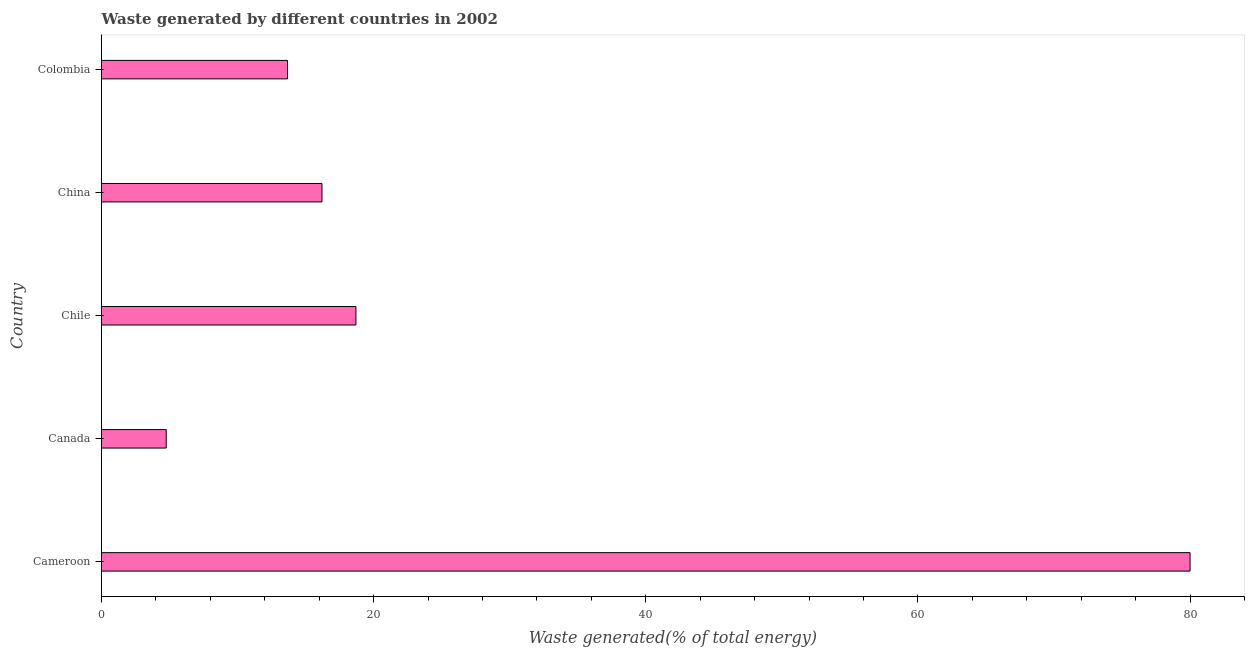What is the title of the graph?
Your response must be concise. Waste generated by different countries in 2002. What is the label or title of the X-axis?
Give a very brief answer. Waste generated(% of total energy). What is the label or title of the Y-axis?
Offer a very short reply. Country. What is the amount of waste generated in Cameroon?
Your answer should be compact. 80. Across all countries, what is the maximum amount of waste generated?
Provide a succinct answer. 80. Across all countries, what is the minimum amount of waste generated?
Provide a succinct answer. 4.76. In which country was the amount of waste generated maximum?
Your answer should be very brief. Cameroon. In which country was the amount of waste generated minimum?
Provide a succinct answer. Canada. What is the sum of the amount of waste generated?
Offer a terse response. 133.33. What is the difference between the amount of waste generated in Cameroon and China?
Provide a short and direct response. 63.8. What is the average amount of waste generated per country?
Your response must be concise. 26.67. What is the median amount of waste generated?
Your answer should be very brief. 16.2. In how many countries, is the amount of waste generated greater than 72 %?
Make the answer very short. 1. What is the ratio of the amount of waste generated in Canada to that in Chile?
Offer a terse response. 0.25. What is the difference between the highest and the second highest amount of waste generated?
Keep it short and to the point. 61.3. Is the sum of the amount of waste generated in Chile and Colombia greater than the maximum amount of waste generated across all countries?
Make the answer very short. No. What is the difference between the highest and the lowest amount of waste generated?
Make the answer very short. 75.25. In how many countries, is the amount of waste generated greater than the average amount of waste generated taken over all countries?
Give a very brief answer. 1. How many bars are there?
Make the answer very short. 5. Are all the bars in the graph horizontal?
Keep it short and to the point. Yes. What is the difference between two consecutive major ticks on the X-axis?
Give a very brief answer. 20. What is the Waste generated(% of total energy) of Cameroon?
Your response must be concise. 80. What is the Waste generated(% of total energy) of Canada?
Give a very brief answer. 4.76. What is the Waste generated(% of total energy) in Chile?
Your response must be concise. 18.7. What is the Waste generated(% of total energy) in China?
Your answer should be very brief. 16.2. What is the Waste generated(% of total energy) in Colombia?
Offer a terse response. 13.67. What is the difference between the Waste generated(% of total energy) in Cameroon and Canada?
Your answer should be very brief. 75.25. What is the difference between the Waste generated(% of total energy) in Cameroon and Chile?
Keep it short and to the point. 61.31. What is the difference between the Waste generated(% of total energy) in Cameroon and China?
Make the answer very short. 63.8. What is the difference between the Waste generated(% of total energy) in Cameroon and Colombia?
Make the answer very short. 66.33. What is the difference between the Waste generated(% of total energy) in Canada and Chile?
Provide a succinct answer. -13.94. What is the difference between the Waste generated(% of total energy) in Canada and China?
Offer a very short reply. -11.45. What is the difference between the Waste generated(% of total energy) in Canada and Colombia?
Offer a terse response. -8.91. What is the difference between the Waste generated(% of total energy) in Chile and China?
Keep it short and to the point. 2.5. What is the difference between the Waste generated(% of total energy) in Chile and Colombia?
Ensure brevity in your answer.  5.03. What is the difference between the Waste generated(% of total energy) in China and Colombia?
Your response must be concise. 2.53. What is the ratio of the Waste generated(% of total energy) in Cameroon to that in Canada?
Offer a very short reply. 16.82. What is the ratio of the Waste generated(% of total energy) in Cameroon to that in Chile?
Your response must be concise. 4.28. What is the ratio of the Waste generated(% of total energy) in Cameroon to that in China?
Your answer should be very brief. 4.94. What is the ratio of the Waste generated(% of total energy) in Cameroon to that in Colombia?
Keep it short and to the point. 5.85. What is the ratio of the Waste generated(% of total energy) in Canada to that in Chile?
Ensure brevity in your answer.  0.25. What is the ratio of the Waste generated(% of total energy) in Canada to that in China?
Your answer should be compact. 0.29. What is the ratio of the Waste generated(% of total energy) in Canada to that in Colombia?
Give a very brief answer. 0.35. What is the ratio of the Waste generated(% of total energy) in Chile to that in China?
Provide a short and direct response. 1.15. What is the ratio of the Waste generated(% of total energy) in Chile to that in Colombia?
Make the answer very short. 1.37. What is the ratio of the Waste generated(% of total energy) in China to that in Colombia?
Provide a succinct answer. 1.19. 